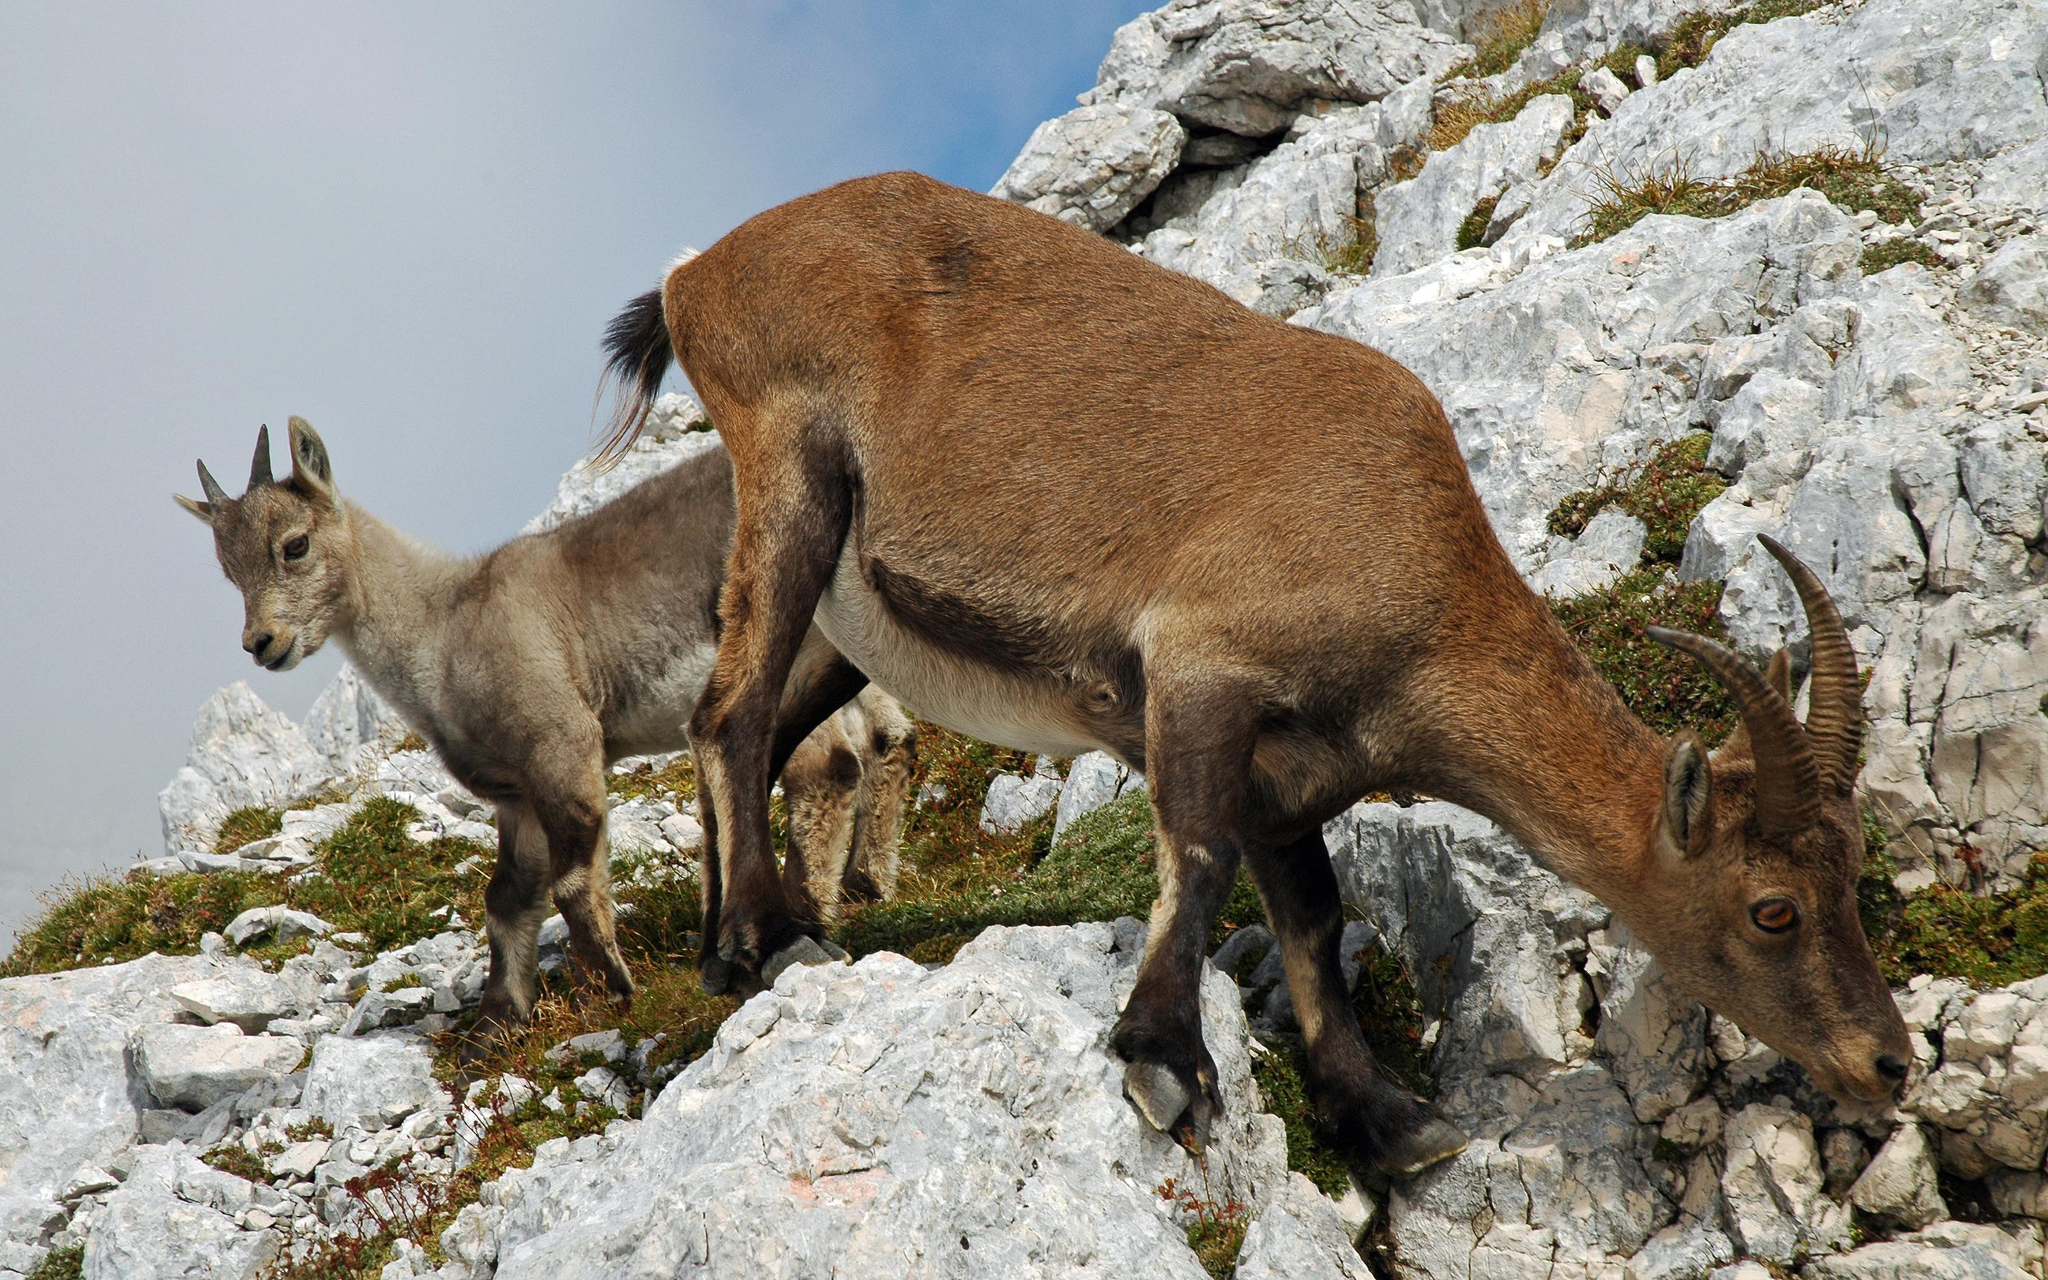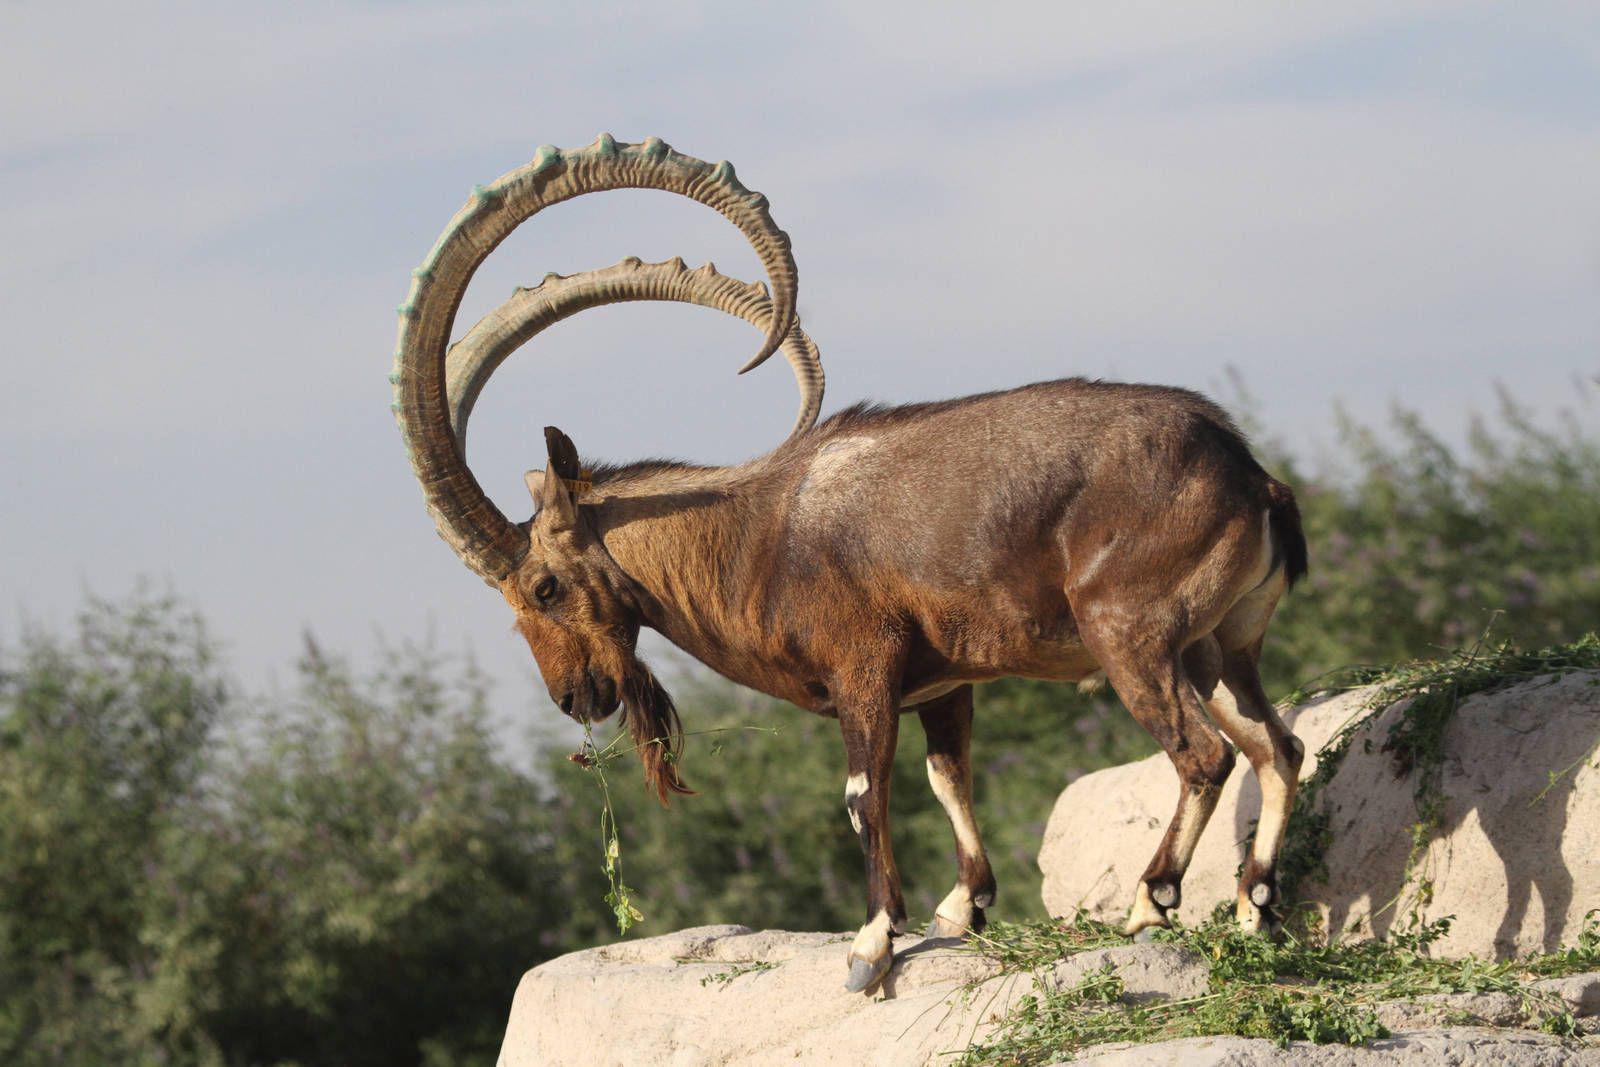The first image is the image on the left, the second image is the image on the right. For the images displayed, is the sentence "There is a total of two animals." factually correct? Answer yes or no. No. 